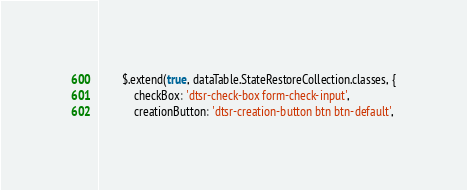<code> <loc_0><loc_0><loc_500><loc_500><_JavaScript_>        $.extend(true, dataTable.StateRestoreCollection.classes, {
            checkBox: 'dtsr-check-box form-check-input',
            creationButton: 'dtsr-creation-button btn btn-default',</code> 